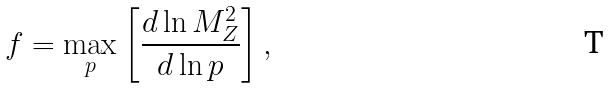Convert formula to latex. <formula><loc_0><loc_0><loc_500><loc_500>f = \max _ { p } \left [ \frac { d \ln M _ { Z } ^ { 2 } } { d \ln p } \right ] ,</formula> 